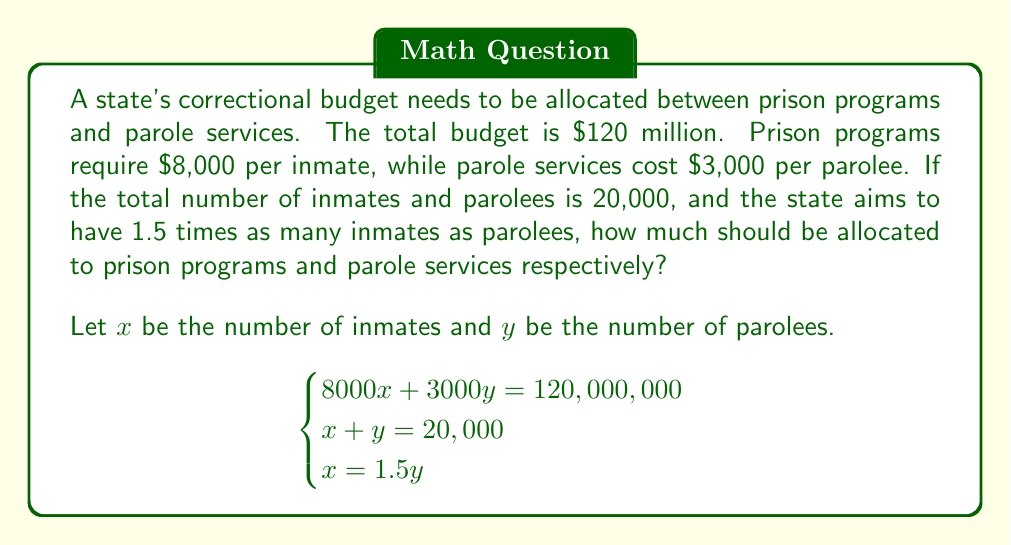Can you solve this math problem? Let's solve this system of equations step by step:

1) From the third equation, we know that $x = 1.5y$. We can substitute this into the second equation:

   $1.5y + y = 20,000$
   $2.5y = 20,000$
   $y = 8,000$

2) Now that we know $y$, we can find $x$:

   $x = 1.5y = 1.5 * 8,000 = 12,000$

3) Let's verify these values satisfy the first equation:

   $8000(12,000) + 3000(8,000) = 120,000,000$
   $96,000,000 + 24,000,000 = 120,000,000$

4) Now we can calculate the budget allocation:

   For prison programs: $8000x = 8000 * 12,000 = 96,000,000$
   For parole services: $3000y = 3000 * 8,000 = 24,000,000$

Therefore, $96 million should be allocated to prison programs and $24 million to parole services.
Answer: $96 million for prison programs, $24 million for parole services 